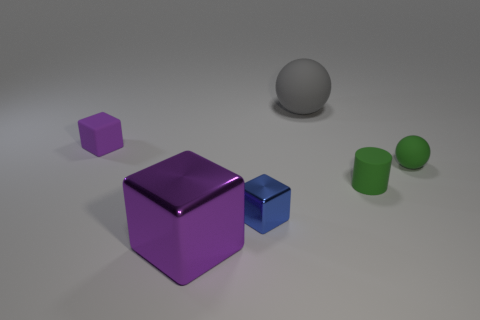Subtract all spheres. How many objects are left? 4 Add 1 tiny blue metal objects. How many objects exist? 7 Add 4 green rubber balls. How many green rubber balls are left? 5 Add 6 small green rubber blocks. How many small green rubber blocks exist? 6 Subtract 0 cyan cylinders. How many objects are left? 6 Subtract all big gray rubber things. Subtract all small matte balls. How many objects are left? 4 